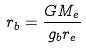<formula> <loc_0><loc_0><loc_500><loc_500>r _ { b } = \frac { G M _ { e } } { g _ { b } r _ { e } }</formula> 